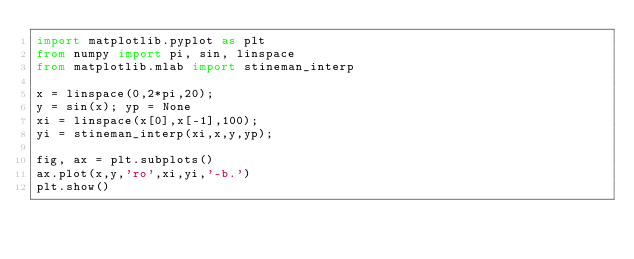Convert code to text. <code><loc_0><loc_0><loc_500><loc_500><_Python_>import matplotlib.pyplot as plt
from numpy import pi, sin, linspace
from matplotlib.mlab import stineman_interp

x = linspace(0,2*pi,20);
y = sin(x); yp = None
xi = linspace(x[0],x[-1],100);
yi = stineman_interp(xi,x,y,yp);

fig, ax = plt.subplots()
ax.plot(x,y,'ro',xi,yi,'-b.')
plt.show()
</code> 